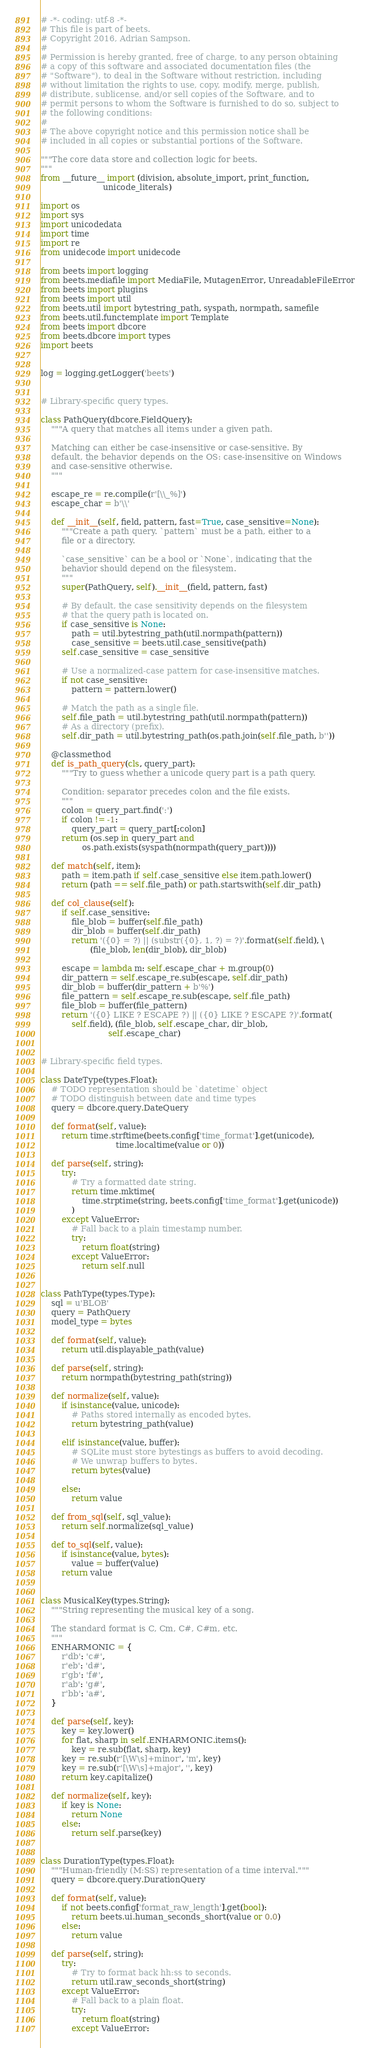Convert code to text. <code><loc_0><loc_0><loc_500><loc_500><_Python_># -*- coding: utf-8 -*-
# This file is part of beets.
# Copyright 2016, Adrian Sampson.
#
# Permission is hereby granted, free of charge, to any person obtaining
# a copy of this software and associated documentation files (the
# "Software"), to deal in the Software without restriction, including
# without limitation the rights to use, copy, modify, merge, publish,
# distribute, sublicense, and/or sell copies of the Software, and to
# permit persons to whom the Software is furnished to do so, subject to
# the following conditions:
#
# The above copyright notice and this permission notice shall be
# included in all copies or substantial portions of the Software.

"""The core data store and collection logic for beets.
"""
from __future__ import (division, absolute_import, print_function,
                        unicode_literals)

import os
import sys
import unicodedata
import time
import re
from unidecode import unidecode

from beets import logging
from beets.mediafile import MediaFile, MutagenError, UnreadableFileError
from beets import plugins
from beets import util
from beets.util import bytestring_path, syspath, normpath, samefile
from beets.util.functemplate import Template
from beets import dbcore
from beets.dbcore import types
import beets


log = logging.getLogger('beets')


# Library-specific query types.

class PathQuery(dbcore.FieldQuery):
    """A query that matches all items under a given path.

    Matching can either be case-insensitive or case-sensitive. By
    default, the behavior depends on the OS: case-insensitive on Windows
    and case-sensitive otherwise.
    """

    escape_re = re.compile(r'[\\_%]')
    escape_char = b'\\'

    def __init__(self, field, pattern, fast=True, case_sensitive=None):
        """Create a path query. `pattern` must be a path, either to a
        file or a directory.

        `case_sensitive` can be a bool or `None`, indicating that the
        behavior should depend on the filesystem.
        """
        super(PathQuery, self).__init__(field, pattern, fast)

        # By default, the case sensitivity depends on the filesystem
        # that the query path is located on.
        if case_sensitive is None:
            path = util.bytestring_path(util.normpath(pattern))
            case_sensitive = beets.util.case_sensitive(path)
        self.case_sensitive = case_sensitive

        # Use a normalized-case pattern for case-insensitive matches.
        if not case_sensitive:
            pattern = pattern.lower()

        # Match the path as a single file.
        self.file_path = util.bytestring_path(util.normpath(pattern))
        # As a directory (prefix).
        self.dir_path = util.bytestring_path(os.path.join(self.file_path, b''))

    @classmethod
    def is_path_query(cls, query_part):
        """Try to guess whether a unicode query part is a path query.

        Condition: separator precedes colon and the file exists.
        """
        colon = query_part.find(':')
        if colon != -1:
            query_part = query_part[:colon]
        return (os.sep in query_part and
                os.path.exists(syspath(normpath(query_part))))

    def match(self, item):
        path = item.path if self.case_sensitive else item.path.lower()
        return (path == self.file_path) or path.startswith(self.dir_path)

    def col_clause(self):
        if self.case_sensitive:
            file_blob = buffer(self.file_path)
            dir_blob = buffer(self.dir_path)
            return '({0} = ?) || (substr({0}, 1, ?) = ?)'.format(self.field), \
                   (file_blob, len(dir_blob), dir_blob)

        escape = lambda m: self.escape_char + m.group(0)
        dir_pattern = self.escape_re.sub(escape, self.dir_path)
        dir_blob = buffer(dir_pattern + b'%')
        file_pattern = self.escape_re.sub(escape, self.file_path)
        file_blob = buffer(file_pattern)
        return '({0} LIKE ? ESCAPE ?) || ({0} LIKE ? ESCAPE ?)'.format(
            self.field), (file_blob, self.escape_char, dir_blob,
                          self.escape_char)


# Library-specific field types.

class DateType(types.Float):
    # TODO representation should be `datetime` object
    # TODO distinguish between date and time types
    query = dbcore.query.DateQuery

    def format(self, value):
        return time.strftime(beets.config['time_format'].get(unicode),
                             time.localtime(value or 0))

    def parse(self, string):
        try:
            # Try a formatted date string.
            return time.mktime(
                time.strptime(string, beets.config['time_format'].get(unicode))
            )
        except ValueError:
            # Fall back to a plain timestamp number.
            try:
                return float(string)
            except ValueError:
                return self.null


class PathType(types.Type):
    sql = u'BLOB'
    query = PathQuery
    model_type = bytes

    def format(self, value):
        return util.displayable_path(value)

    def parse(self, string):
        return normpath(bytestring_path(string))

    def normalize(self, value):
        if isinstance(value, unicode):
            # Paths stored internally as encoded bytes.
            return bytestring_path(value)

        elif isinstance(value, buffer):
            # SQLite must store bytestings as buffers to avoid decoding.
            # We unwrap buffers to bytes.
            return bytes(value)

        else:
            return value

    def from_sql(self, sql_value):
        return self.normalize(sql_value)

    def to_sql(self, value):
        if isinstance(value, bytes):
            value = buffer(value)
        return value


class MusicalKey(types.String):
    """String representing the musical key of a song.

    The standard format is C, Cm, C#, C#m, etc.
    """
    ENHARMONIC = {
        r'db': 'c#',
        r'eb': 'd#',
        r'gb': 'f#',
        r'ab': 'g#',
        r'bb': 'a#',
    }

    def parse(self, key):
        key = key.lower()
        for flat, sharp in self.ENHARMONIC.items():
            key = re.sub(flat, sharp, key)
        key = re.sub(r'[\W\s]+minor', 'm', key)
        key = re.sub(r'[\W\s]+major', '', key)
        return key.capitalize()

    def normalize(self, key):
        if key is None:
            return None
        else:
            return self.parse(key)


class DurationType(types.Float):
    """Human-friendly (M:SS) representation of a time interval."""
    query = dbcore.query.DurationQuery

    def format(self, value):
        if not beets.config['format_raw_length'].get(bool):
            return beets.ui.human_seconds_short(value or 0.0)
        else:
            return value

    def parse(self, string):
        try:
            # Try to format back hh:ss to seconds.
            return util.raw_seconds_short(string)
        except ValueError:
            # Fall back to a plain float.
            try:
                return float(string)
            except ValueError:</code> 